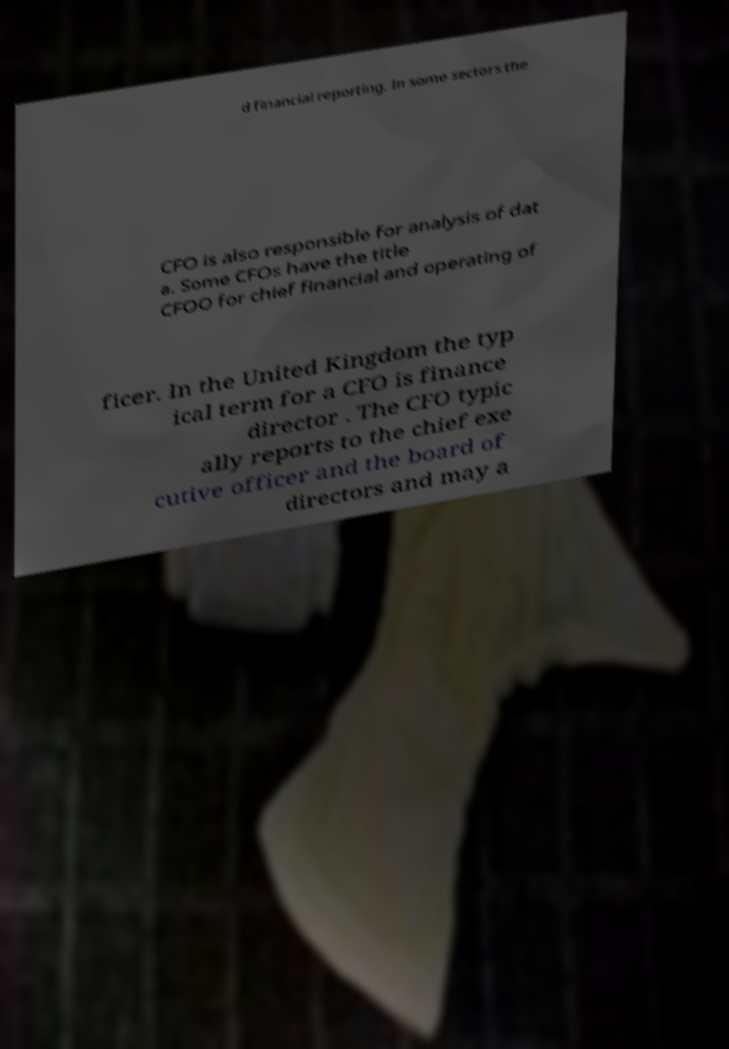Please identify and transcribe the text found in this image. d financial reporting. In some sectors the CFO is also responsible for analysis of dat a. Some CFOs have the title CFOO for chief financial and operating of ficer. In the United Kingdom the typ ical term for a CFO is finance director . The CFO typic ally reports to the chief exe cutive officer and the board of directors and may a 